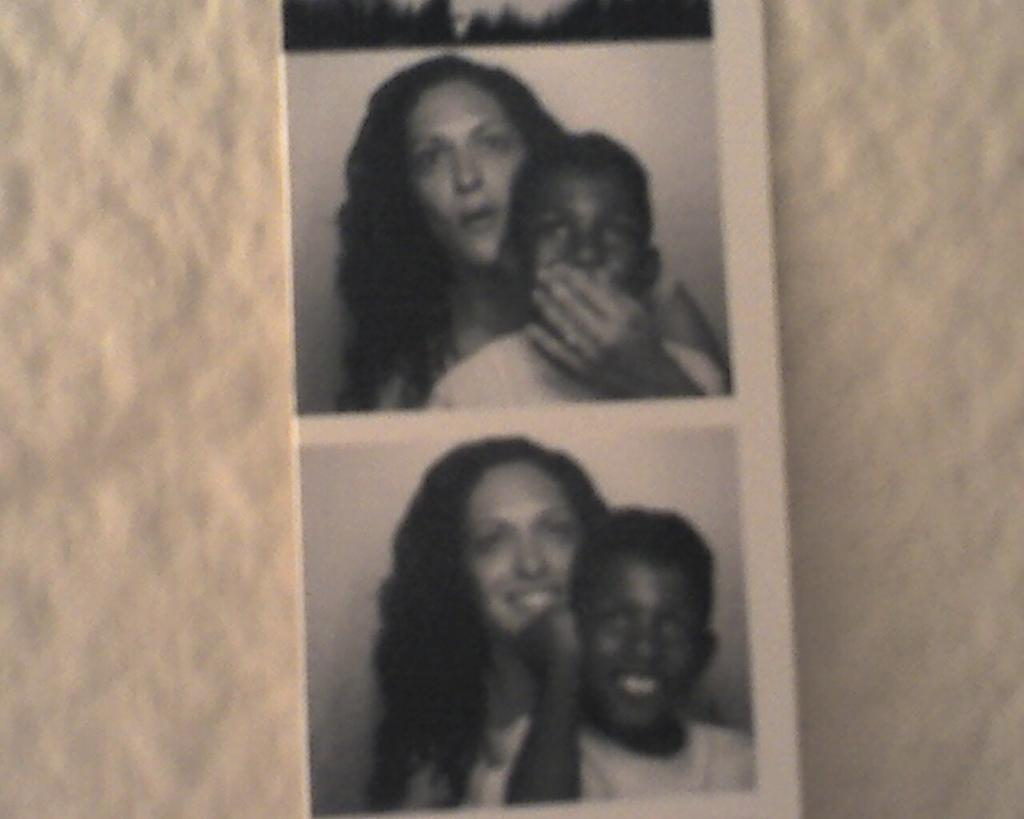What is the main subject of the image? There is a photograph in the image. Who or what can be seen in the photograph? The photograph contains a woman and a boy. What can be seen in the background of the photograph? There is a wall visible in the background of the photograph. How many pies are being baked in the image? There are no pies or baking activity present in the image. What part of the earth can be seen in the image? The image does not show any specific part of the earth; it contains a photograph of a woman and a boy. 